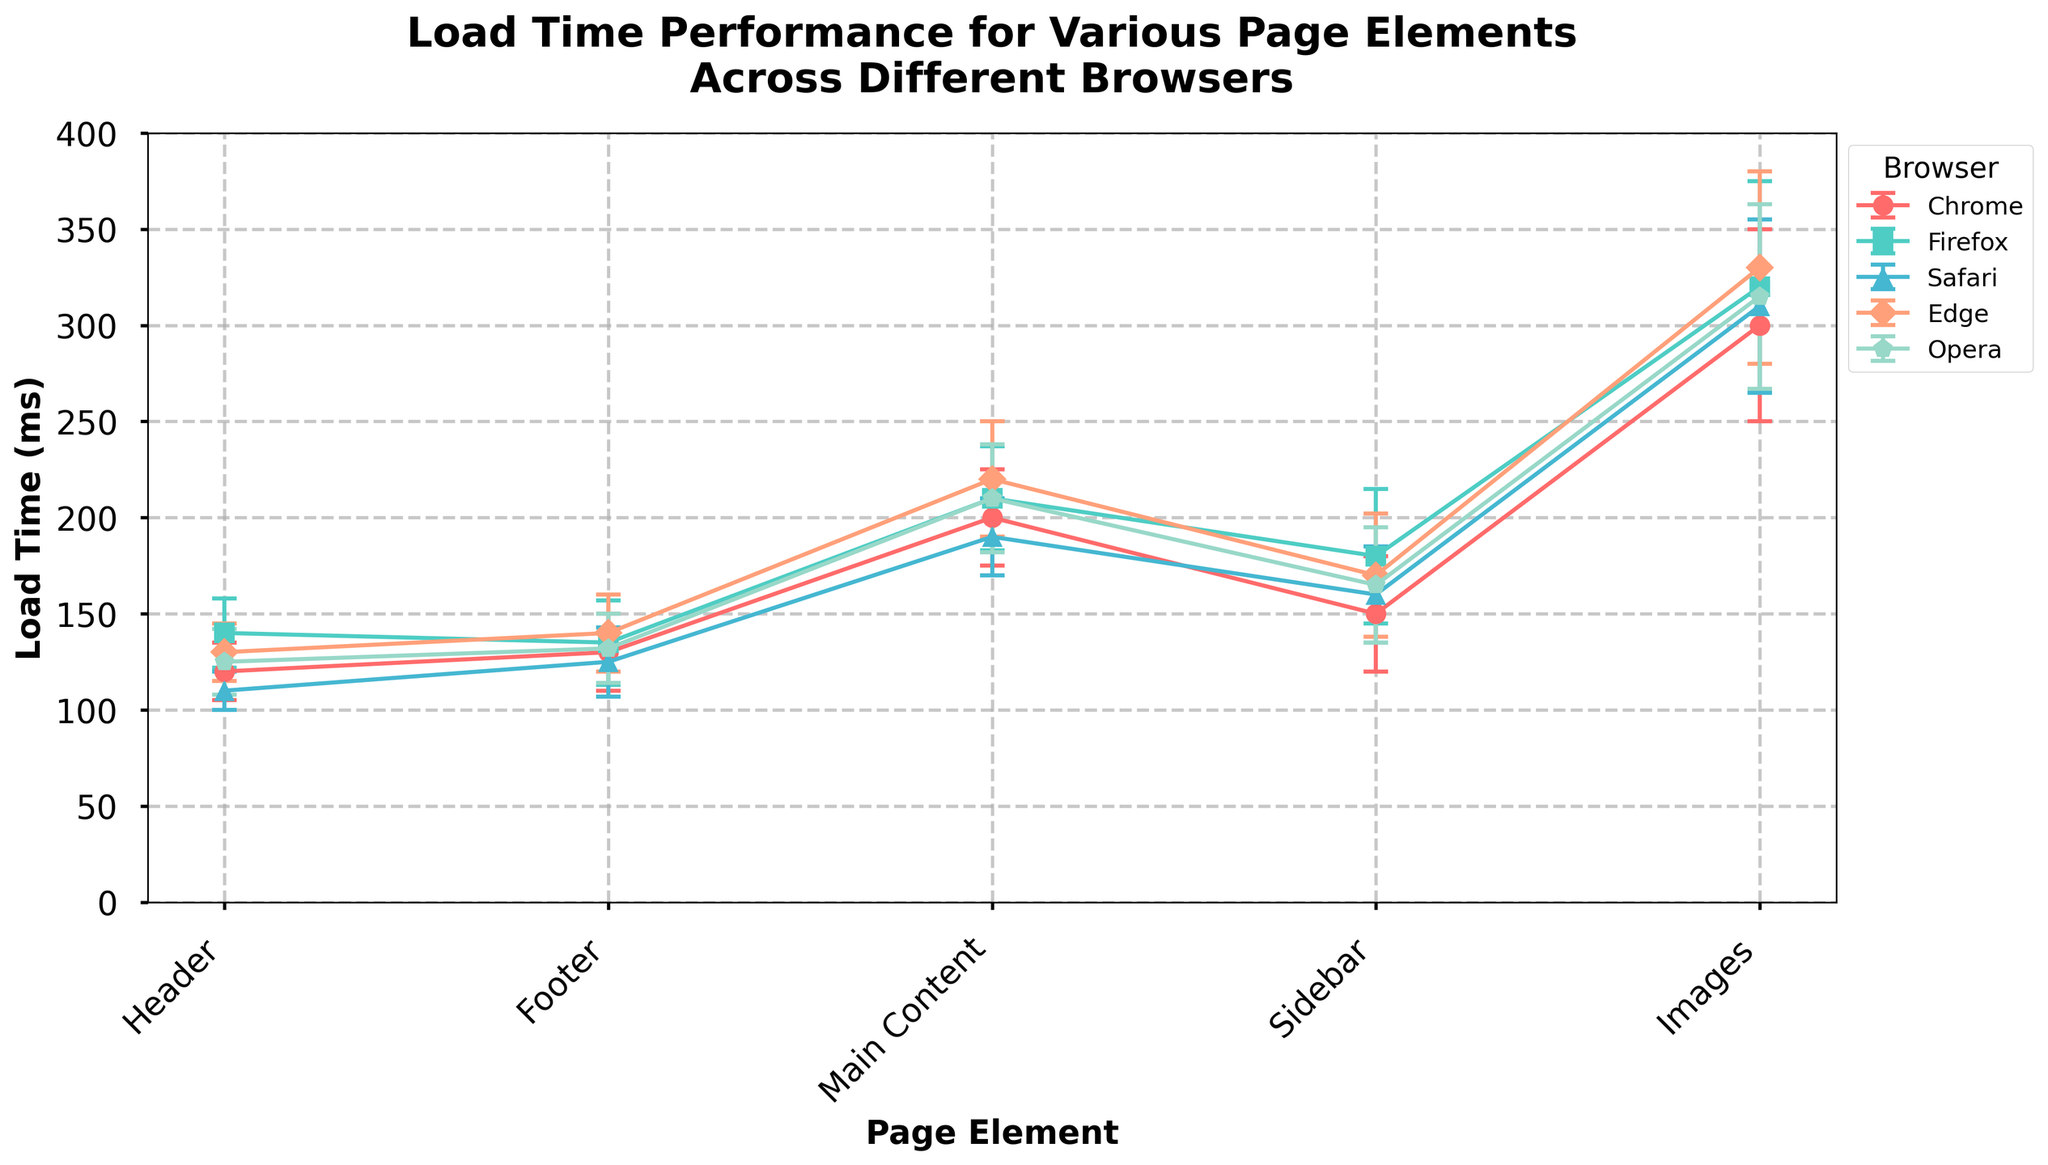How many page elements are being compared in the plot? The x-axis represents the page elements being analyzed. We can see the different page elements listed along the x-axis. By counting these, we determine the number of unique page elements.
Answer: 5 Which browser has the fastest average load time for the header? Look at the error bars representing the header load time for each browser. Identify the lowest mean value in these bars. This will be the browser with the quickest load time for the header.
Answer: Safari Among all the page elements, which one exhibits the greatest variability in load time across any browser? Examine the size of the error bars for each page element across all browsers. The element with the largest error bar exhibits the greatest variability.
Answer: Images in Firefox What is the mean load time for main content in Edge? Find the data point representing the mean load time for the main content page element in Edge. This is directly labeled in the plot.
Answer: 220 ms Which browser has the highest overall mean load time for images? Look at the error bars representing the load time for images across each browser. The one with the highest mean value indicates the browser with the longest load duration for images.
Answer: Edge By how much does Firefox's load time for the sidebar exceed Safari's? Determine the mean load time for the sidebar in both Firefox and Safari from the plot. Subtract Safari's mean load time from Firefox's mean load time.
Answer: 20 ms Which page element generally shows the highest load times across all browsers? Identify the page element that consistently has the highest mean load times across most browsers by comparing the different elements on average.
Answer: Images Is the load time for the footer significantly different between Chrome and Opera? Compare the mean load times of the footers in Chrome and Opera by looking at their positions on the plot. Determine if they are close or significantly distant.
Answer: No, they are close (135 ms for Chrome vs. 132 ms for Opera) How does the average load time for the header in Chrome compare to that in Firefox? Compare the mean load times for the header between Chrome and Firefox by observing their respective points and determining how much one is greater than the other.
Answer: Chrome's header loads faster by 20 ms 